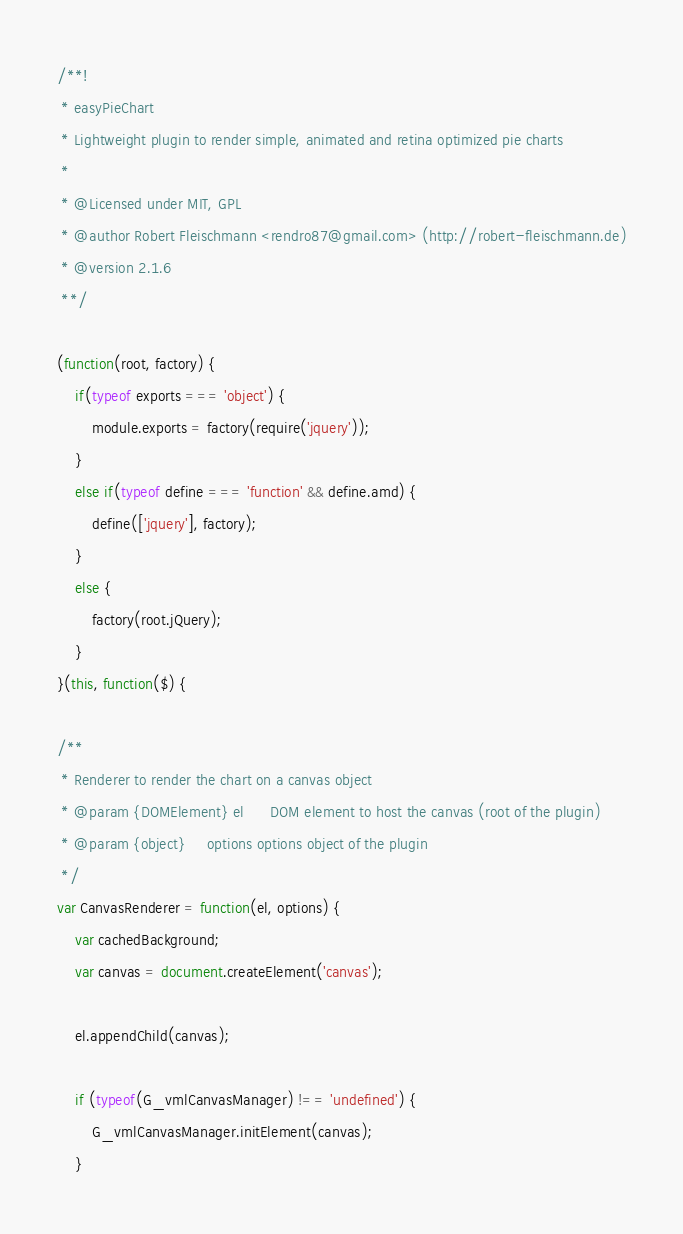Convert code to text. <code><loc_0><loc_0><loc_500><loc_500><_JavaScript_>/**!
 * easyPieChart
 * Lightweight plugin to render simple, animated and retina optimized pie charts
 *
 * @Licensed under MIT, GPL 
 * @author Robert Fleischmann <rendro87@gmail.com> (http://robert-fleischmann.de)
 * @version 2.1.6
 **/

(function(root, factory) {
    if(typeof exports === 'object') {
        module.exports = factory(require('jquery'));
    }
    else if(typeof define === 'function' && define.amd) {
        define(['jquery'], factory);
    }
    else {
        factory(root.jQuery);
    }
}(this, function($) {

/**
 * Renderer to render the chart on a canvas object
 * @param {DOMElement} el      DOM element to host the canvas (root of the plugin)
 * @param {object}     options options object of the plugin
 */
var CanvasRenderer = function(el, options) {
	var cachedBackground;
	var canvas = document.createElement('canvas');

	el.appendChild(canvas);

	if (typeof(G_vmlCanvasManager) !== 'undefined') {
		G_vmlCanvasManager.initElement(canvas);
	}
</code> 